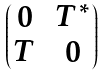Convert formula to latex. <formula><loc_0><loc_0><loc_500><loc_500>\begin{pmatrix} 0 & T ^ { \ast } \\ T & 0 \end{pmatrix}</formula> 